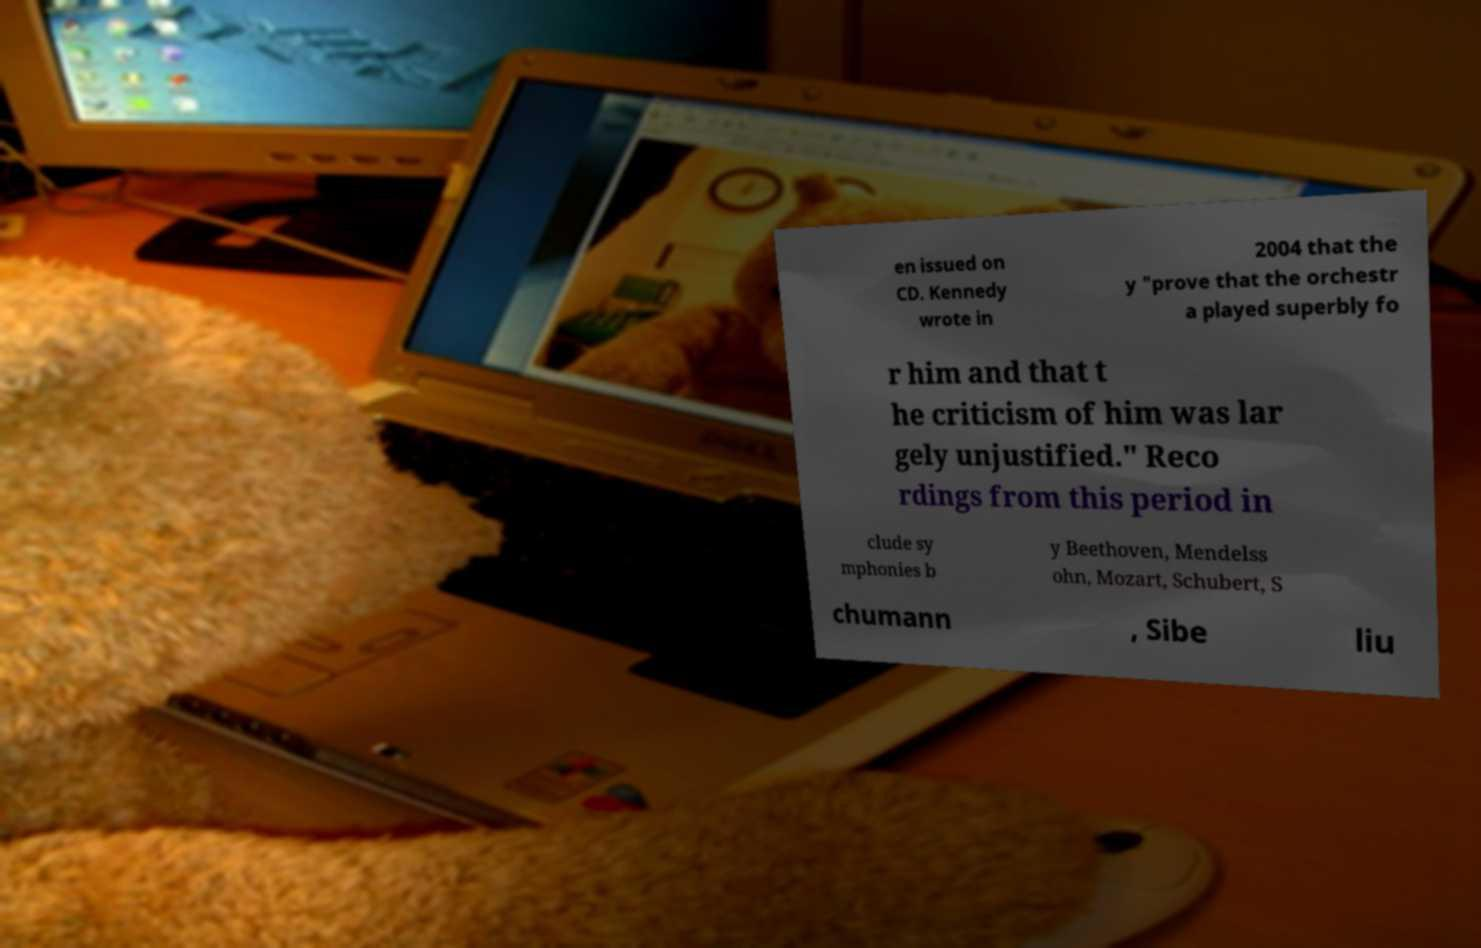What messages or text are displayed in this image? I need them in a readable, typed format. en issued on CD. Kennedy wrote in 2004 that the y "prove that the orchestr a played superbly fo r him and that t he criticism of him was lar gely unjustified." Reco rdings from this period in clude sy mphonies b y Beethoven, Mendelss ohn, Mozart, Schubert, S chumann , Sibe liu 